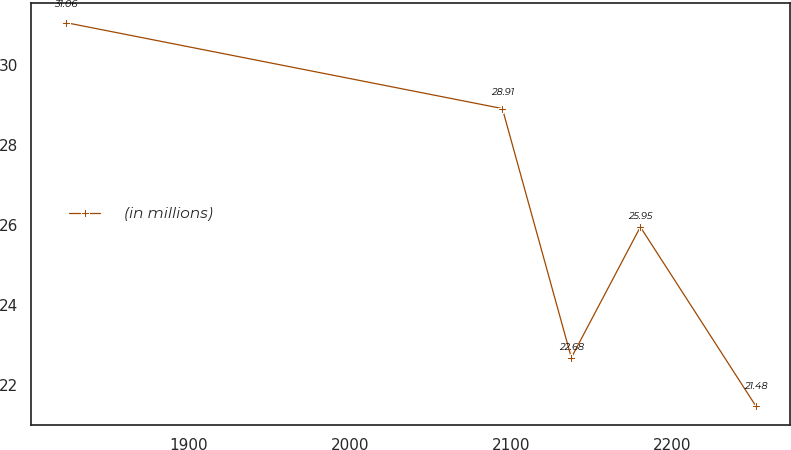Convert chart to OTSL. <chart><loc_0><loc_0><loc_500><loc_500><line_chart><ecel><fcel>(in millions)<nl><fcel>1823.63<fcel>31.06<nl><fcel>2094.83<fcel>28.91<nl><fcel>2137.68<fcel>22.68<nl><fcel>2180.53<fcel>25.95<nl><fcel>2252.11<fcel>21.48<nl></chart> 